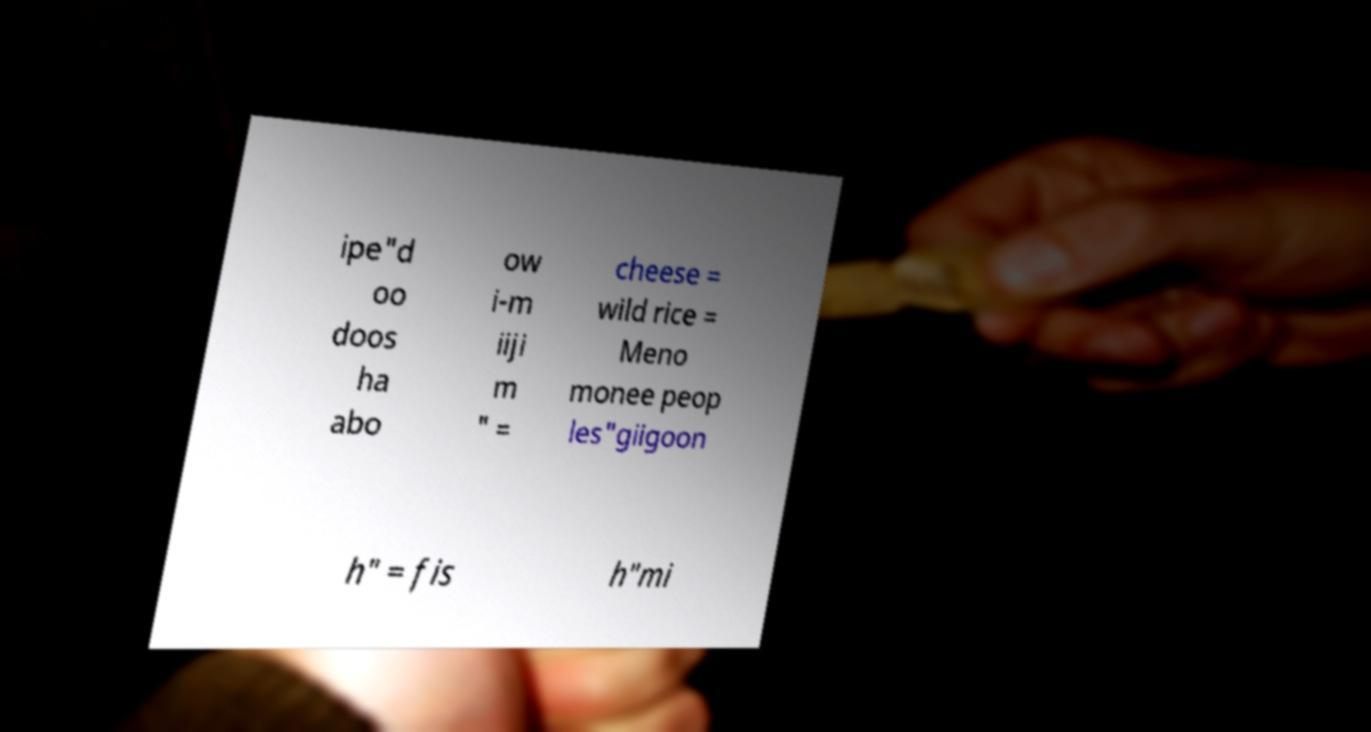I need the written content from this picture converted into text. Can you do that? ipe"d oo doos ha abo ow i-m iiji m " = cheese = wild rice = Meno monee peop les"giigoon h" = fis h"mi 